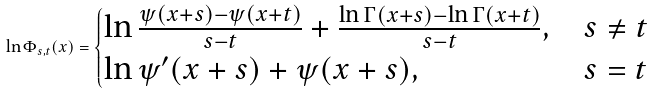Convert formula to latex. <formula><loc_0><loc_0><loc_500><loc_500>\ln \Phi _ { s , t } ( x ) = \begin{cases} \ln \frac { \psi ( x + s ) - \psi ( x + t ) } { s - t } + \frac { \ln \Gamma ( x + s ) - \ln \Gamma ( x + t ) } { s - t } , & s \ne t \\ \ln \psi ^ { \prime } ( x + s ) + \psi ( x + s ) , & s = t \end{cases}</formula> 